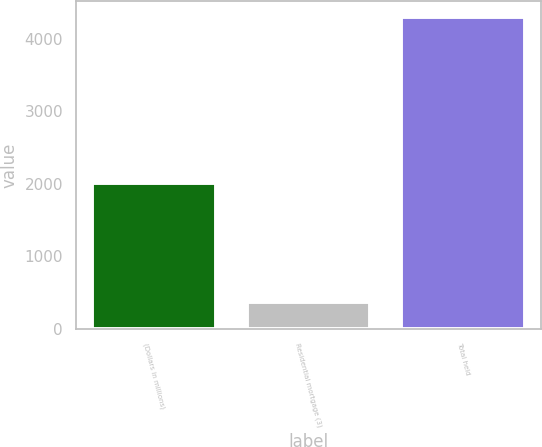<chart> <loc_0><loc_0><loc_500><loc_500><bar_chart><fcel>(Dollars in millions)<fcel>Residential mortgage (3)<fcel>Total held<nl><fcel>2008<fcel>372<fcel>4311<nl></chart> 